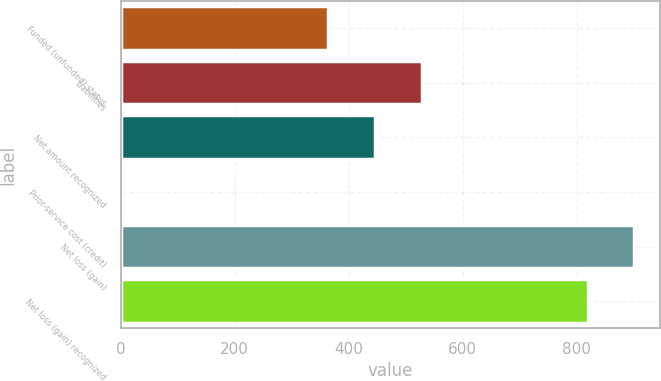<chart> <loc_0><loc_0><loc_500><loc_500><bar_chart><fcel>Funded (unfunded) status<fcel>Liabilities<fcel>Net amount recognized<fcel>Prior-service cost (credit)<fcel>Net loss (gain)<fcel>Net loss (gain) recognized<nl><fcel>364<fcel>527.8<fcel>445.9<fcel>2<fcel>900.9<fcel>819<nl></chart> 